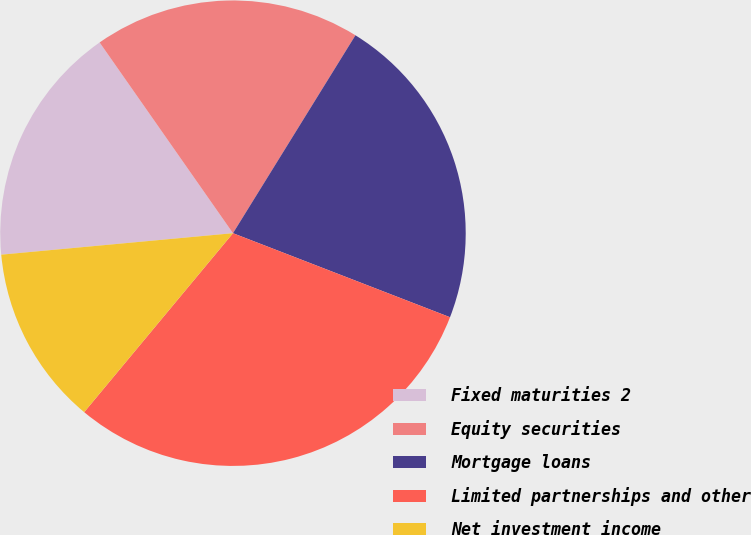Convert chart to OTSL. <chart><loc_0><loc_0><loc_500><loc_500><pie_chart><fcel>Fixed maturities 2<fcel>Equity securities<fcel>Mortgage loans<fcel>Limited partnerships and other<fcel>Net investment income<nl><fcel>16.76%<fcel>18.53%<fcel>22.06%<fcel>30.16%<fcel>12.49%<nl></chart> 